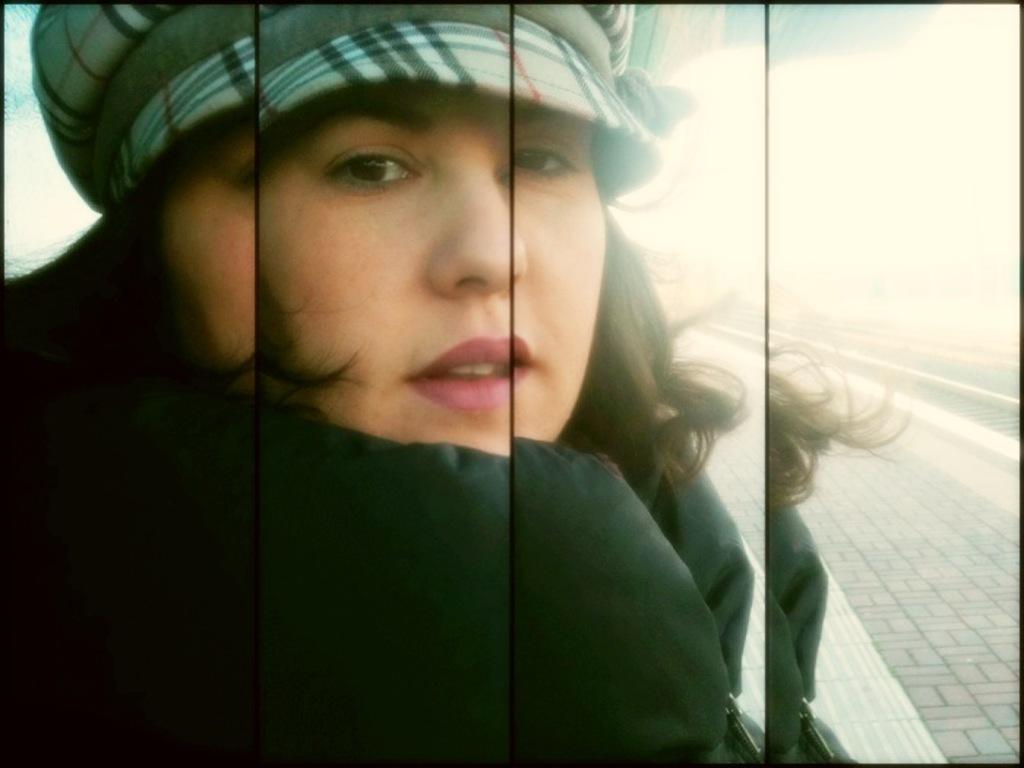What type of photograph is shown in the image? The image is a college photograph. Can you describe the person in the photograph? There is a girl in the photograph. Where is the girl positioned in the image? The girl is standing in the front. What is the girl doing in the photograph? The girl is posing for the camera. How many minutes does the girl wave in the image? There is no indication in the image that the girl is waving, so it cannot be determined how many minutes she might be waving. 